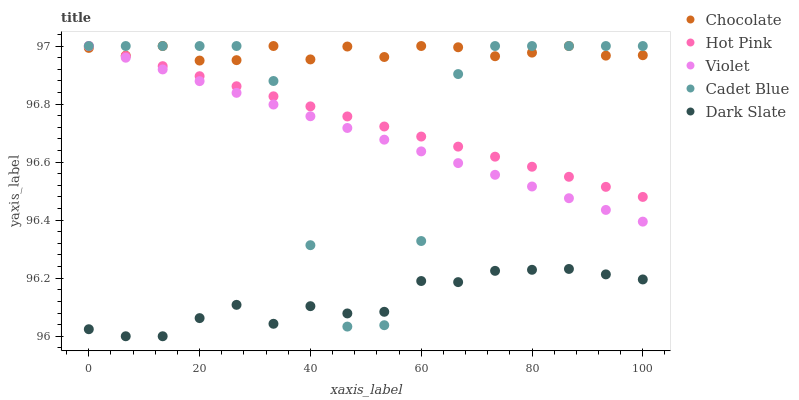Does Dark Slate have the minimum area under the curve?
Answer yes or no. Yes. Does Chocolate have the maximum area under the curve?
Answer yes or no. Yes. Does Violet have the minimum area under the curve?
Answer yes or no. No. Does Violet have the maximum area under the curve?
Answer yes or no. No. Is Violet the smoothest?
Answer yes or no. Yes. Is Cadet Blue the roughest?
Answer yes or no. Yes. Is Hot Pink the smoothest?
Answer yes or no. No. Is Hot Pink the roughest?
Answer yes or no. No. Does Dark Slate have the lowest value?
Answer yes or no. Yes. Does Violet have the lowest value?
Answer yes or no. No. Does Chocolate have the highest value?
Answer yes or no. Yes. Does Dark Slate have the highest value?
Answer yes or no. No. Is Dark Slate less than Chocolate?
Answer yes or no. Yes. Is Violet greater than Dark Slate?
Answer yes or no. Yes. Does Chocolate intersect Cadet Blue?
Answer yes or no. Yes. Is Chocolate less than Cadet Blue?
Answer yes or no. No. Is Chocolate greater than Cadet Blue?
Answer yes or no. No. Does Dark Slate intersect Chocolate?
Answer yes or no. No. 